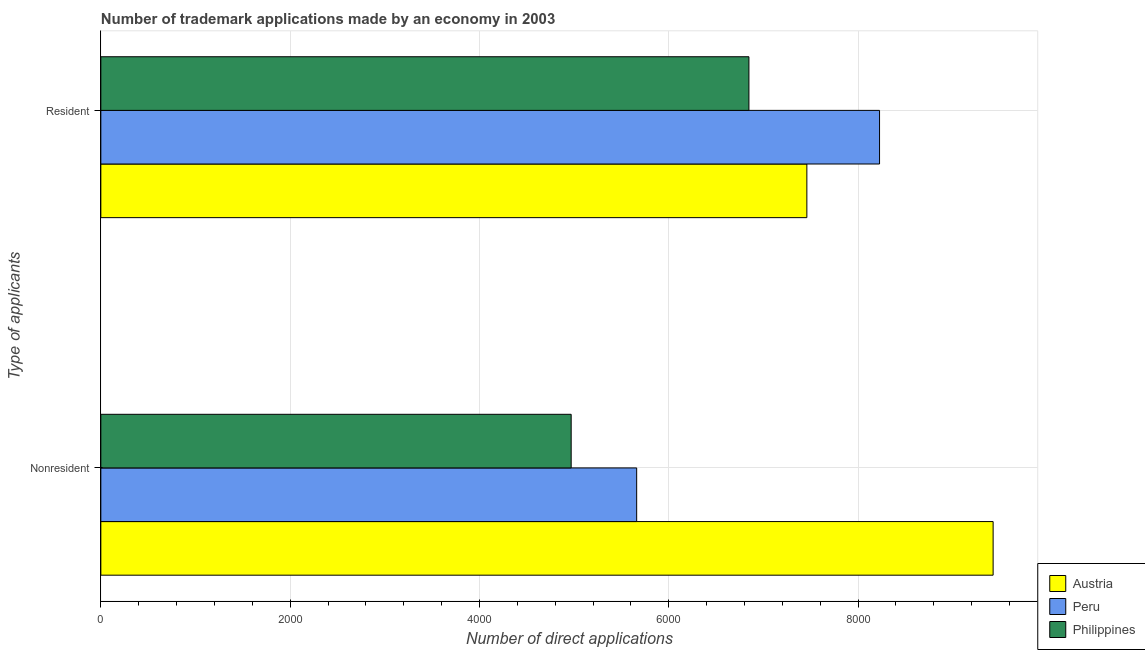Are the number of bars per tick equal to the number of legend labels?
Give a very brief answer. Yes. How many bars are there on the 1st tick from the bottom?
Your answer should be compact. 3. What is the label of the 2nd group of bars from the top?
Provide a succinct answer. Nonresident. What is the number of trademark applications made by non residents in Peru?
Your response must be concise. 5661. Across all countries, what is the maximum number of trademark applications made by non residents?
Your response must be concise. 9427. Across all countries, what is the minimum number of trademark applications made by non residents?
Your response must be concise. 4969. In which country was the number of trademark applications made by non residents minimum?
Provide a succinct answer. Philippines. What is the total number of trademark applications made by non residents in the graph?
Keep it short and to the point. 2.01e+04. What is the difference between the number of trademark applications made by residents in Peru and that in Philippines?
Ensure brevity in your answer.  1380. What is the difference between the number of trademark applications made by non residents in Philippines and the number of trademark applications made by residents in Peru?
Provide a short and direct response. -3258. What is the average number of trademark applications made by residents per country?
Ensure brevity in your answer.  7511. What is the difference between the number of trademark applications made by non residents and number of trademark applications made by residents in Austria?
Your answer should be compact. 1968. In how many countries, is the number of trademark applications made by residents greater than 4400 ?
Offer a terse response. 3. What is the ratio of the number of trademark applications made by non residents in Austria to that in Peru?
Keep it short and to the point. 1.67. Is the number of trademark applications made by non residents in Philippines less than that in Austria?
Offer a very short reply. Yes. What does the 3rd bar from the bottom in Nonresident represents?
Offer a very short reply. Philippines. Are all the bars in the graph horizontal?
Your answer should be compact. Yes. How many countries are there in the graph?
Keep it short and to the point. 3. What is the difference between two consecutive major ticks on the X-axis?
Keep it short and to the point. 2000. Are the values on the major ticks of X-axis written in scientific E-notation?
Your response must be concise. No. Does the graph contain any zero values?
Give a very brief answer. No. Does the graph contain grids?
Offer a terse response. Yes. Where does the legend appear in the graph?
Keep it short and to the point. Bottom right. How many legend labels are there?
Provide a short and direct response. 3. How are the legend labels stacked?
Ensure brevity in your answer.  Vertical. What is the title of the graph?
Provide a short and direct response. Number of trademark applications made by an economy in 2003. What is the label or title of the X-axis?
Your answer should be compact. Number of direct applications. What is the label or title of the Y-axis?
Your answer should be compact. Type of applicants. What is the Number of direct applications of Austria in Nonresident?
Keep it short and to the point. 9427. What is the Number of direct applications of Peru in Nonresident?
Give a very brief answer. 5661. What is the Number of direct applications of Philippines in Nonresident?
Keep it short and to the point. 4969. What is the Number of direct applications in Austria in Resident?
Ensure brevity in your answer.  7459. What is the Number of direct applications of Peru in Resident?
Provide a short and direct response. 8227. What is the Number of direct applications of Philippines in Resident?
Your answer should be very brief. 6847. Across all Type of applicants, what is the maximum Number of direct applications of Austria?
Provide a succinct answer. 9427. Across all Type of applicants, what is the maximum Number of direct applications of Peru?
Your response must be concise. 8227. Across all Type of applicants, what is the maximum Number of direct applications in Philippines?
Your answer should be very brief. 6847. Across all Type of applicants, what is the minimum Number of direct applications in Austria?
Give a very brief answer. 7459. Across all Type of applicants, what is the minimum Number of direct applications in Peru?
Offer a very short reply. 5661. Across all Type of applicants, what is the minimum Number of direct applications of Philippines?
Keep it short and to the point. 4969. What is the total Number of direct applications in Austria in the graph?
Your response must be concise. 1.69e+04. What is the total Number of direct applications in Peru in the graph?
Your answer should be very brief. 1.39e+04. What is the total Number of direct applications of Philippines in the graph?
Give a very brief answer. 1.18e+04. What is the difference between the Number of direct applications in Austria in Nonresident and that in Resident?
Offer a very short reply. 1968. What is the difference between the Number of direct applications of Peru in Nonresident and that in Resident?
Your answer should be compact. -2566. What is the difference between the Number of direct applications of Philippines in Nonresident and that in Resident?
Keep it short and to the point. -1878. What is the difference between the Number of direct applications in Austria in Nonresident and the Number of direct applications in Peru in Resident?
Your answer should be compact. 1200. What is the difference between the Number of direct applications of Austria in Nonresident and the Number of direct applications of Philippines in Resident?
Offer a very short reply. 2580. What is the difference between the Number of direct applications in Peru in Nonresident and the Number of direct applications in Philippines in Resident?
Give a very brief answer. -1186. What is the average Number of direct applications in Austria per Type of applicants?
Ensure brevity in your answer.  8443. What is the average Number of direct applications of Peru per Type of applicants?
Provide a short and direct response. 6944. What is the average Number of direct applications in Philippines per Type of applicants?
Provide a succinct answer. 5908. What is the difference between the Number of direct applications in Austria and Number of direct applications in Peru in Nonresident?
Your answer should be compact. 3766. What is the difference between the Number of direct applications of Austria and Number of direct applications of Philippines in Nonresident?
Offer a very short reply. 4458. What is the difference between the Number of direct applications of Peru and Number of direct applications of Philippines in Nonresident?
Offer a very short reply. 692. What is the difference between the Number of direct applications of Austria and Number of direct applications of Peru in Resident?
Provide a short and direct response. -768. What is the difference between the Number of direct applications of Austria and Number of direct applications of Philippines in Resident?
Keep it short and to the point. 612. What is the difference between the Number of direct applications of Peru and Number of direct applications of Philippines in Resident?
Your answer should be very brief. 1380. What is the ratio of the Number of direct applications in Austria in Nonresident to that in Resident?
Make the answer very short. 1.26. What is the ratio of the Number of direct applications of Peru in Nonresident to that in Resident?
Provide a succinct answer. 0.69. What is the ratio of the Number of direct applications in Philippines in Nonresident to that in Resident?
Offer a terse response. 0.73. What is the difference between the highest and the second highest Number of direct applications of Austria?
Offer a very short reply. 1968. What is the difference between the highest and the second highest Number of direct applications of Peru?
Make the answer very short. 2566. What is the difference between the highest and the second highest Number of direct applications of Philippines?
Ensure brevity in your answer.  1878. What is the difference between the highest and the lowest Number of direct applications in Austria?
Offer a terse response. 1968. What is the difference between the highest and the lowest Number of direct applications in Peru?
Your answer should be very brief. 2566. What is the difference between the highest and the lowest Number of direct applications in Philippines?
Keep it short and to the point. 1878. 